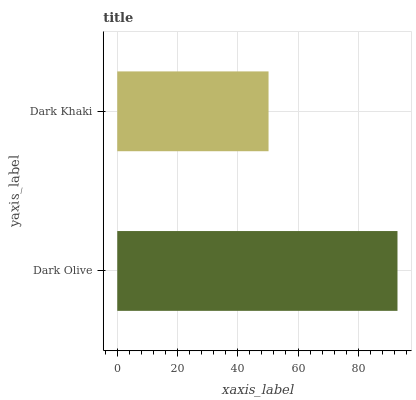Is Dark Khaki the minimum?
Answer yes or no. Yes. Is Dark Olive the maximum?
Answer yes or no. Yes. Is Dark Khaki the maximum?
Answer yes or no. No. Is Dark Olive greater than Dark Khaki?
Answer yes or no. Yes. Is Dark Khaki less than Dark Olive?
Answer yes or no. Yes. Is Dark Khaki greater than Dark Olive?
Answer yes or no. No. Is Dark Olive less than Dark Khaki?
Answer yes or no. No. Is Dark Olive the high median?
Answer yes or no. Yes. Is Dark Khaki the low median?
Answer yes or no. Yes. Is Dark Khaki the high median?
Answer yes or no. No. Is Dark Olive the low median?
Answer yes or no. No. 